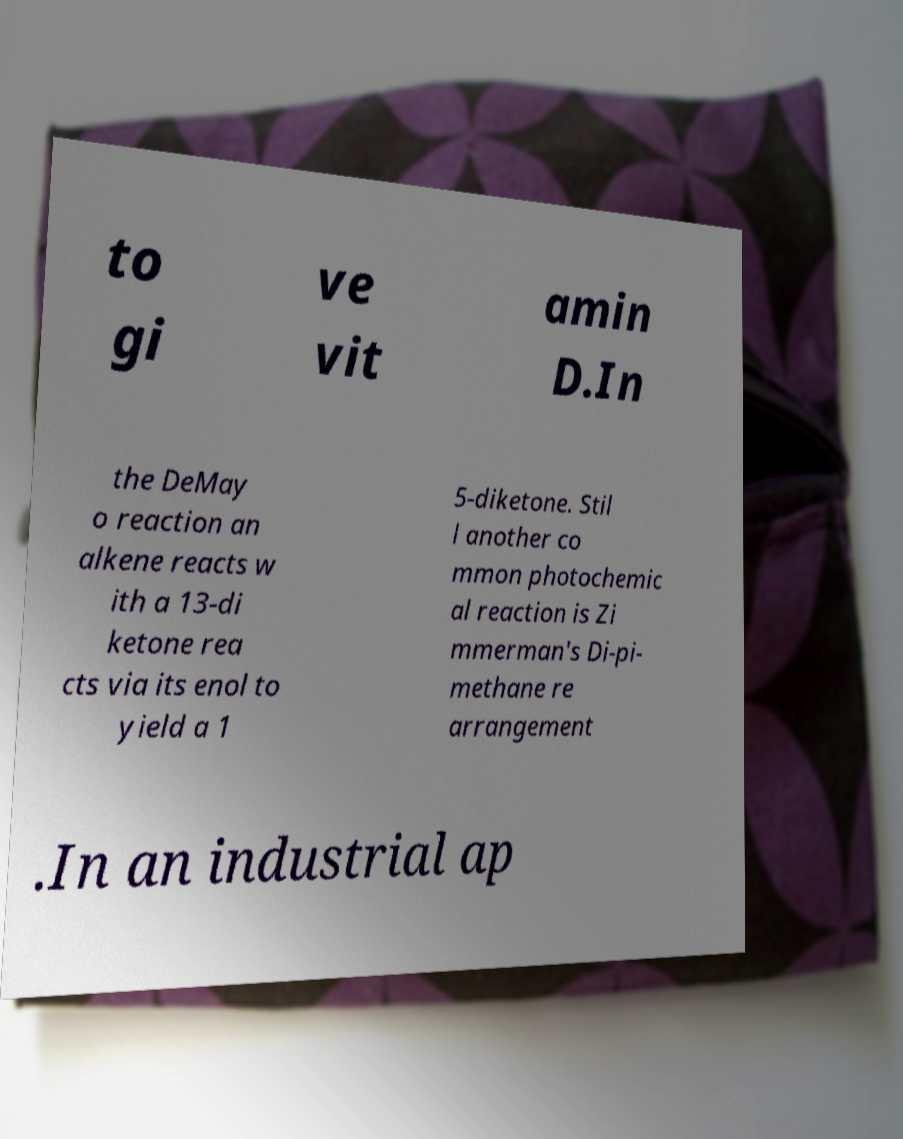Can you read and provide the text displayed in the image?This photo seems to have some interesting text. Can you extract and type it out for me? to gi ve vit amin D.In the DeMay o reaction an alkene reacts w ith a 13-di ketone rea cts via its enol to yield a 1 5-diketone. Stil l another co mmon photochemic al reaction is Zi mmerman's Di-pi- methane re arrangement .In an industrial ap 